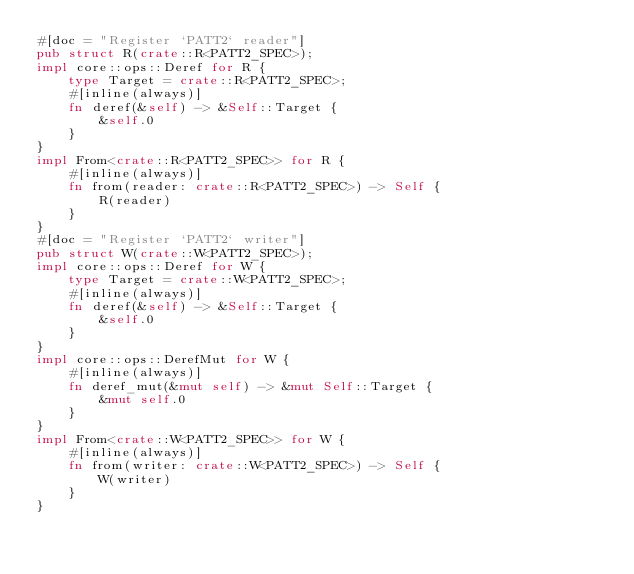<code> <loc_0><loc_0><loc_500><loc_500><_Rust_>#[doc = "Register `PATT2` reader"]
pub struct R(crate::R<PATT2_SPEC>);
impl core::ops::Deref for R {
    type Target = crate::R<PATT2_SPEC>;
    #[inline(always)]
    fn deref(&self) -> &Self::Target {
        &self.0
    }
}
impl From<crate::R<PATT2_SPEC>> for R {
    #[inline(always)]
    fn from(reader: crate::R<PATT2_SPEC>) -> Self {
        R(reader)
    }
}
#[doc = "Register `PATT2` writer"]
pub struct W(crate::W<PATT2_SPEC>);
impl core::ops::Deref for W {
    type Target = crate::W<PATT2_SPEC>;
    #[inline(always)]
    fn deref(&self) -> &Self::Target {
        &self.0
    }
}
impl core::ops::DerefMut for W {
    #[inline(always)]
    fn deref_mut(&mut self) -> &mut Self::Target {
        &mut self.0
    }
}
impl From<crate::W<PATT2_SPEC>> for W {
    #[inline(always)]
    fn from(writer: crate::W<PATT2_SPEC>) -> Self {
        W(writer)
    }
}</code> 